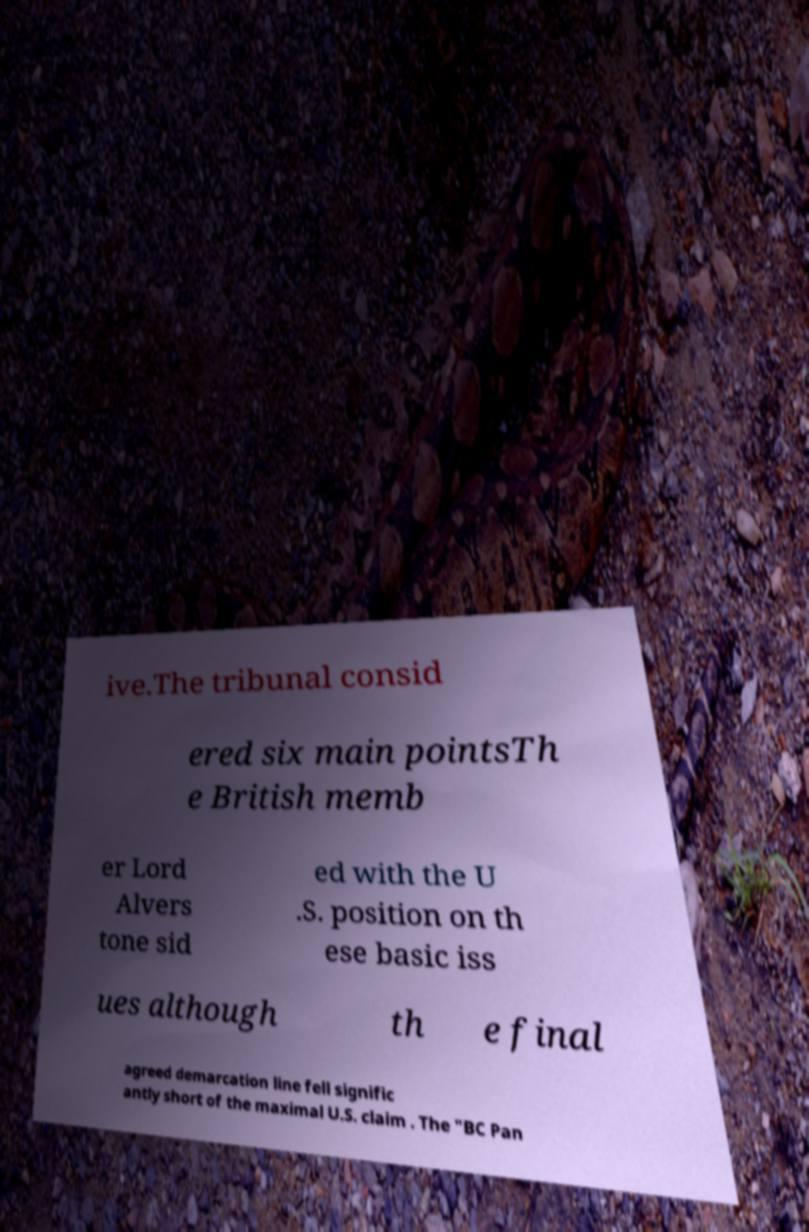What messages or text are displayed in this image? I need them in a readable, typed format. ive.The tribunal consid ered six main pointsTh e British memb er Lord Alvers tone sid ed with the U .S. position on th ese basic iss ues although th e final agreed demarcation line fell signific antly short of the maximal U.S. claim . The "BC Pan 